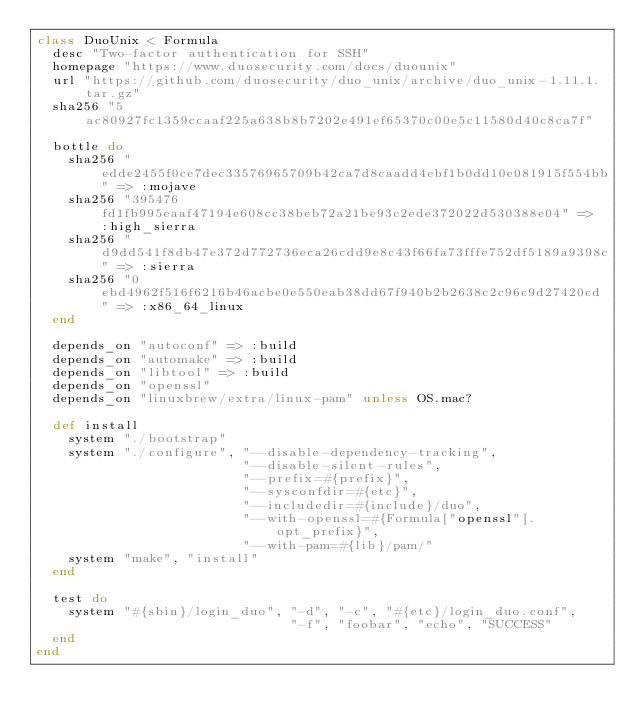<code> <loc_0><loc_0><loc_500><loc_500><_Ruby_>class DuoUnix < Formula
  desc "Two-factor authentication for SSH"
  homepage "https://www.duosecurity.com/docs/duounix"
  url "https://github.com/duosecurity/duo_unix/archive/duo_unix-1.11.1.tar.gz"
  sha256 "5ac80927fc1359ccaaf225a638b8b7202e491ef65370c00e5c11580d40c8ca7f"

  bottle do
    sha256 "edde2455f0ce7dec33576965709b42ca7d8caadd4ebf1b0dd10e081915f554bb" => :mojave
    sha256 "395476fd1fb995eaaf47194e608cc38beb72a21be93c2ede372022d530388e04" => :high_sierra
    sha256 "d9dd541f8db47e372d772736eca26cdd9e8c43f66fa73fffe752df5189a9398c" => :sierra
    sha256 "0ebd4962f516f6216b46acbe0e550eab38dd67f940b2b2638c2c96c9d27420cd" => :x86_64_linux
  end

  depends_on "autoconf" => :build
  depends_on "automake" => :build
  depends_on "libtool" => :build
  depends_on "openssl"
  depends_on "linuxbrew/extra/linux-pam" unless OS.mac?

  def install
    system "./bootstrap"
    system "./configure", "--disable-dependency-tracking",
                          "--disable-silent-rules",
                          "--prefix=#{prefix}",
                          "--sysconfdir=#{etc}",
                          "--includedir=#{include}/duo",
                          "--with-openssl=#{Formula["openssl"].opt_prefix}",
                          "--with-pam=#{lib}/pam/"
    system "make", "install"
  end

  test do
    system "#{sbin}/login_duo", "-d", "-c", "#{etc}/login_duo.conf",
                                "-f", "foobar", "echo", "SUCCESS"
  end
end
</code> 